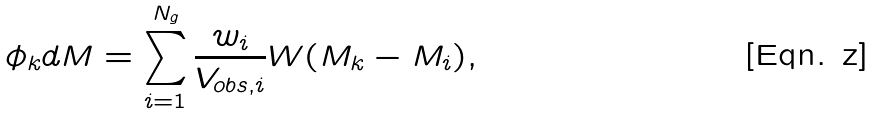Convert formula to latex. <formula><loc_0><loc_0><loc_500><loc_500>\phi _ { k } d M = \sum ^ { N _ { g } } _ { i = 1 } \frac { w _ { i } } { V _ { o b s , i } } W ( M _ { k } - M _ { i } ) ,</formula> 